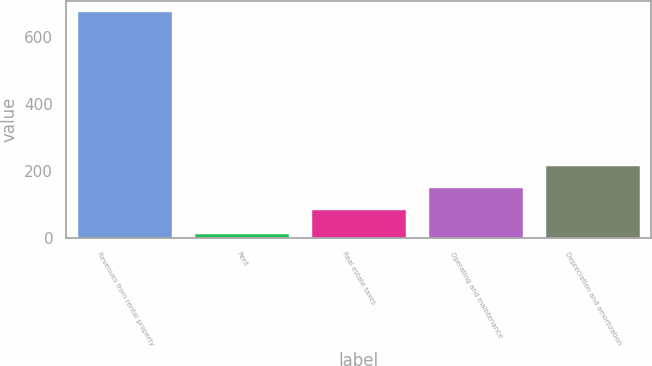<chart> <loc_0><loc_0><loc_500><loc_500><bar_chart><fcel>Revenues from rental property<fcel>Rent<fcel>Real estate taxes<fcel>Operating and maintenance<fcel>Depreciation and amortization<nl><fcel>674.5<fcel>12.1<fcel>82.5<fcel>148.74<fcel>214.98<nl></chart> 